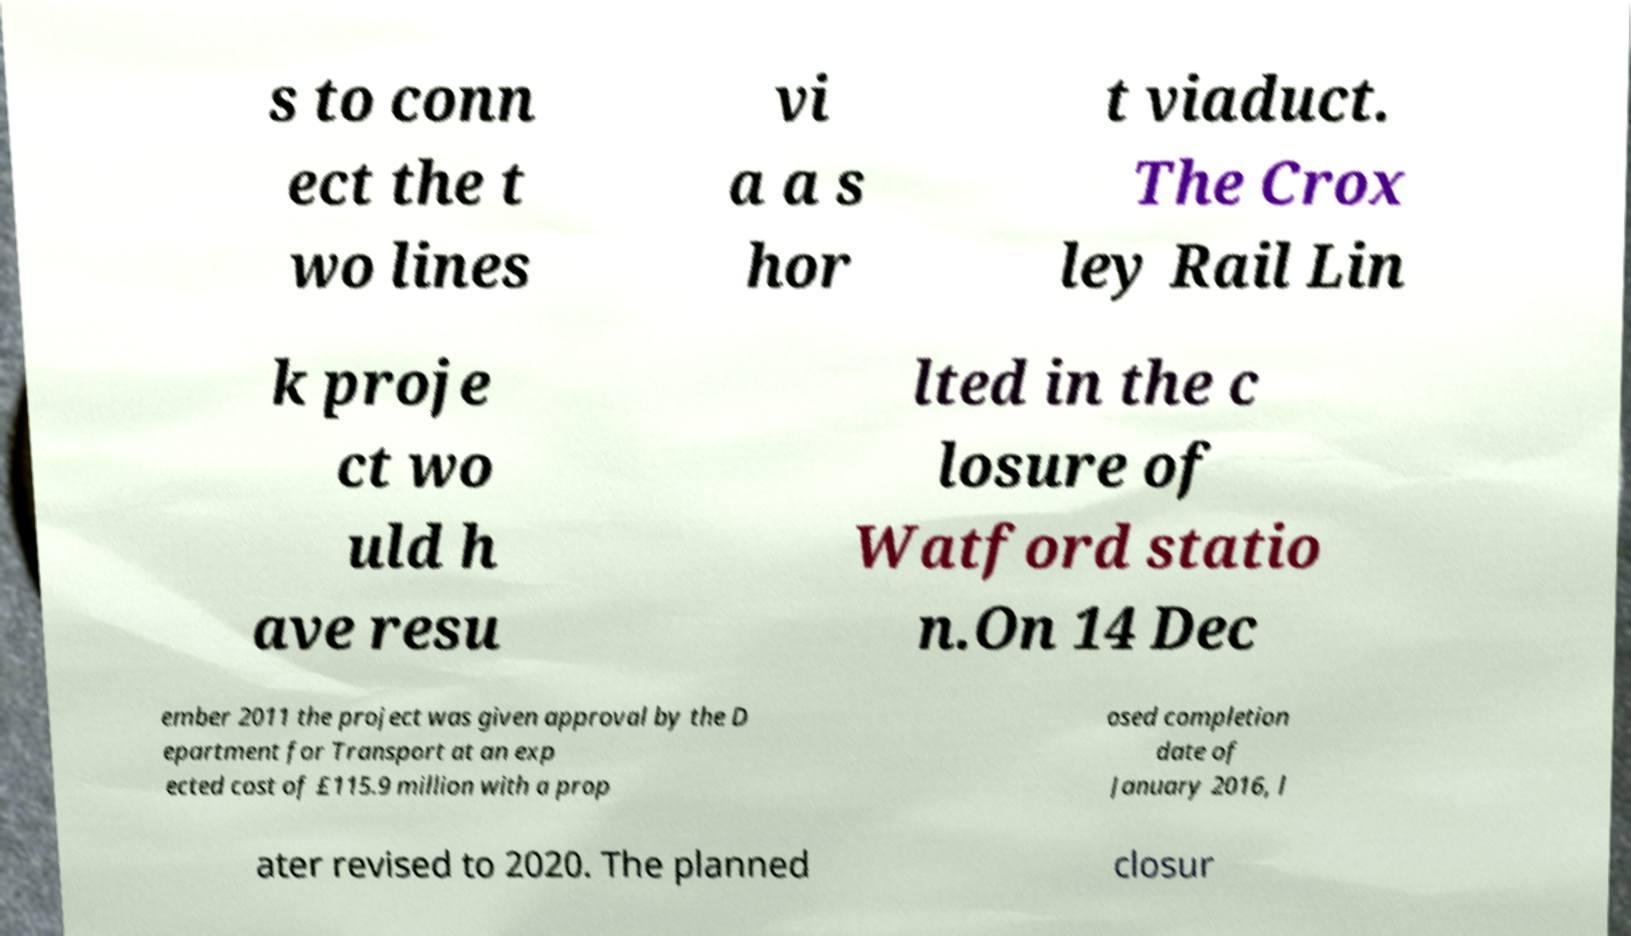Please read and relay the text visible in this image. What does it say? s to conn ect the t wo lines vi a a s hor t viaduct. The Crox ley Rail Lin k proje ct wo uld h ave resu lted in the c losure of Watford statio n.On 14 Dec ember 2011 the project was given approval by the D epartment for Transport at an exp ected cost of £115.9 million with a prop osed completion date of January 2016, l ater revised to 2020. The planned closur 